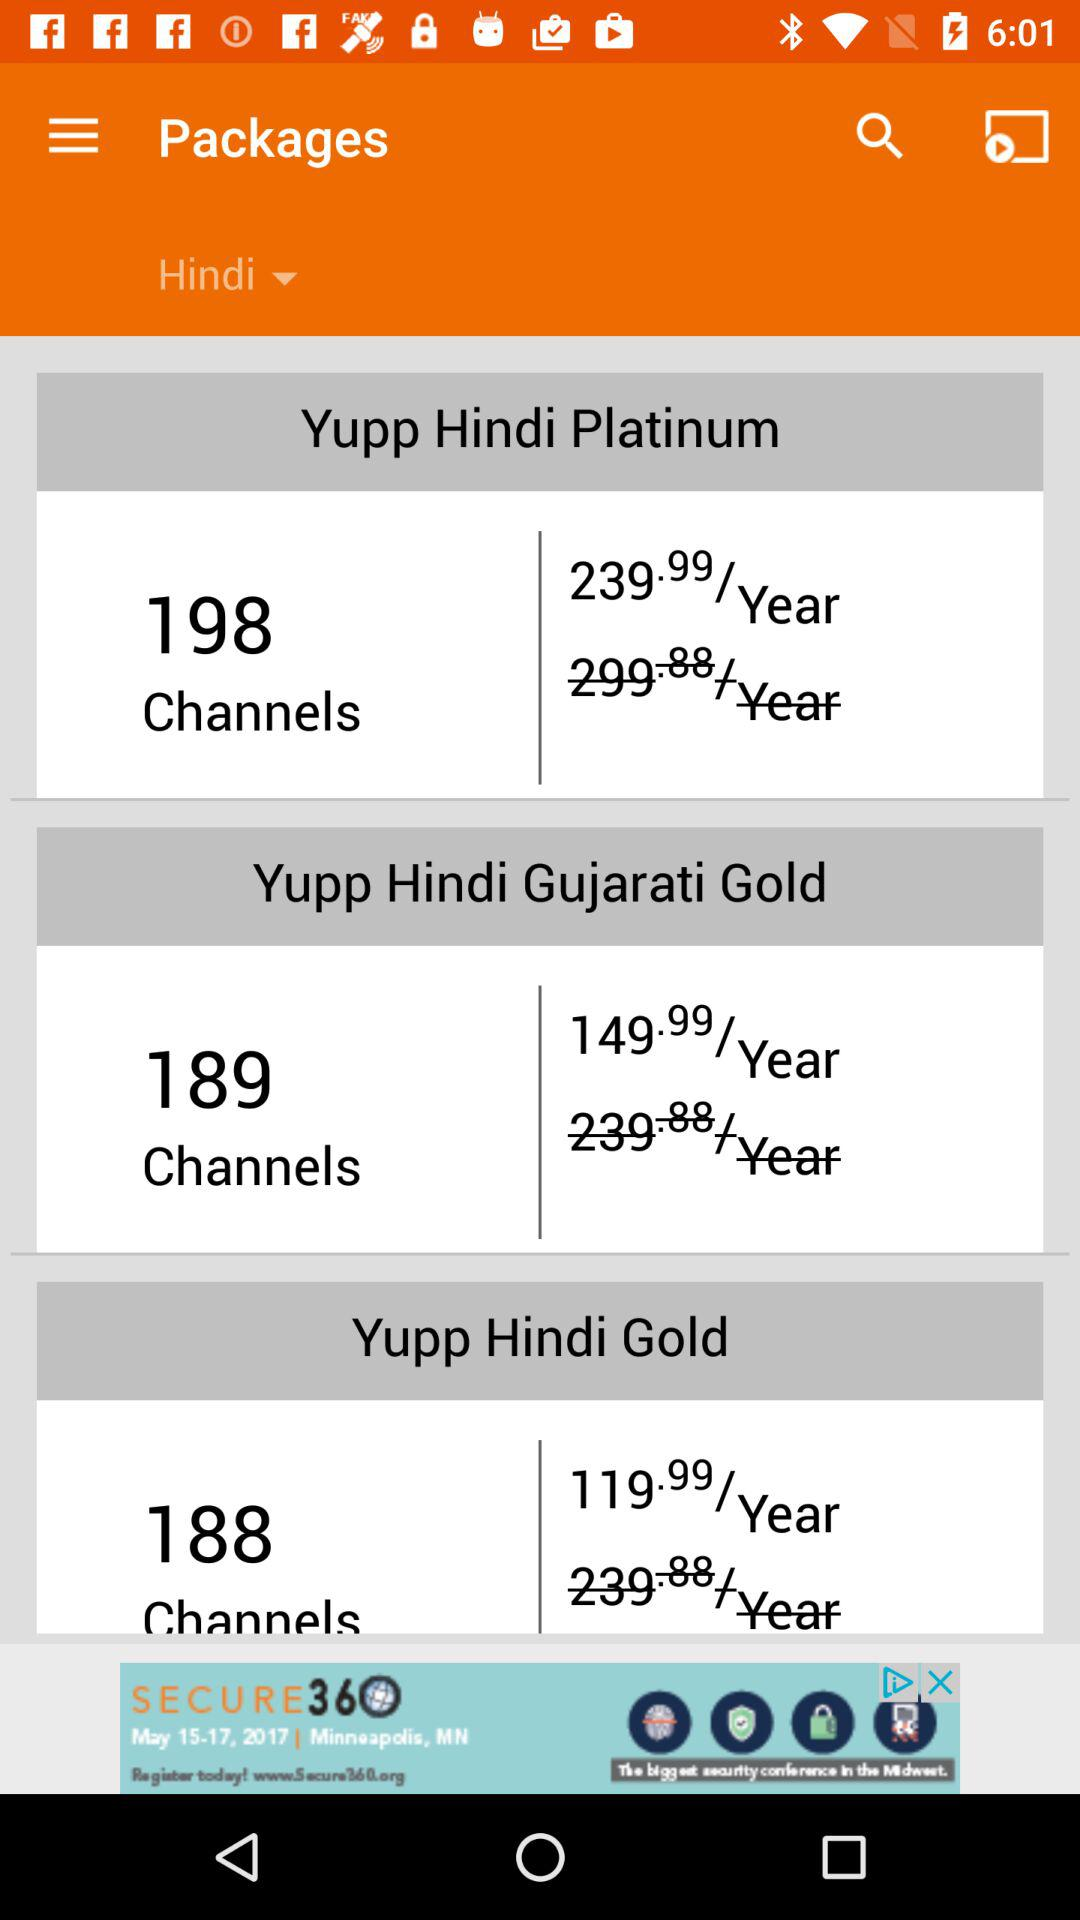What was the previous price of the "Yupp Hindi Gold" package? The previous price of the "Yupp Hindi Gold" package was 239.88 per year. 